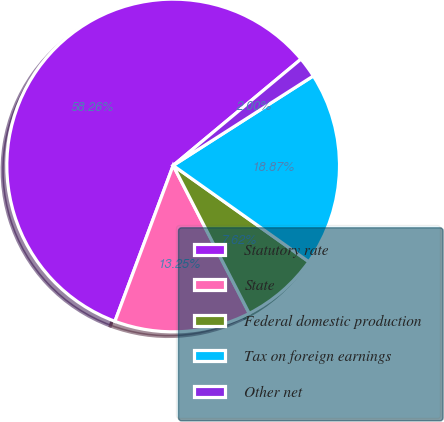Convert chart. <chart><loc_0><loc_0><loc_500><loc_500><pie_chart><fcel>Statutory rate<fcel>State<fcel>Federal domestic production<fcel>Tax on foreign earnings<fcel>Other net<nl><fcel>58.26%<fcel>13.25%<fcel>7.62%<fcel>18.87%<fcel>2.0%<nl></chart> 